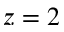Convert formula to latex. <formula><loc_0><loc_0><loc_500><loc_500>z = 2</formula> 